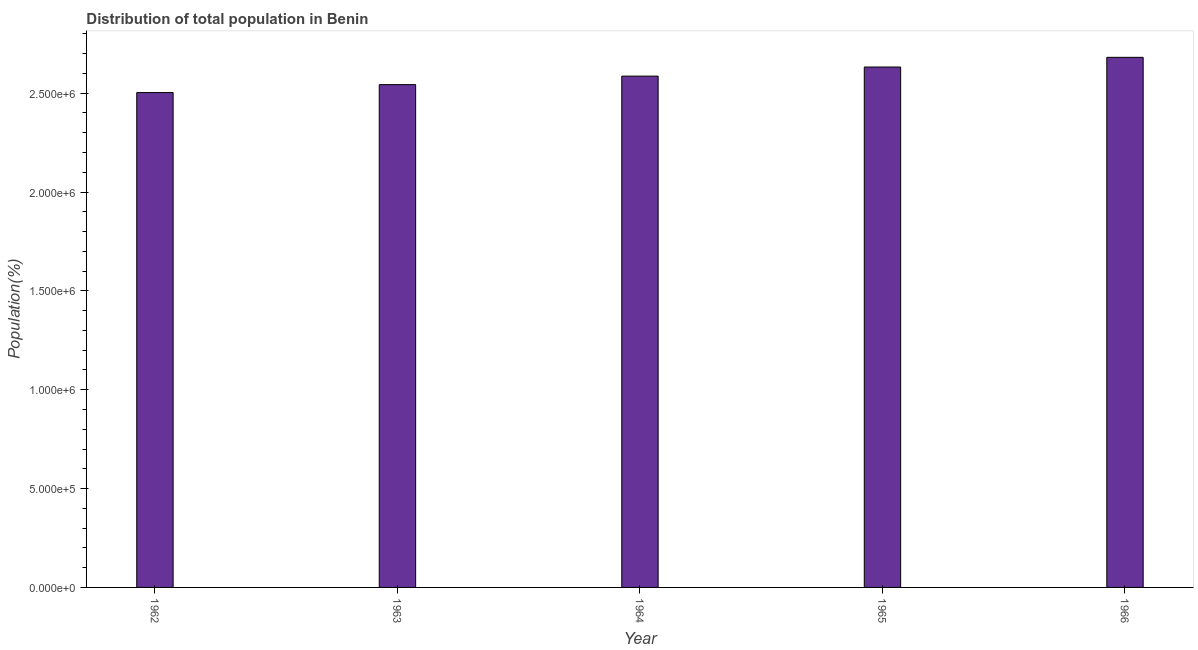Does the graph contain any zero values?
Make the answer very short. No. Does the graph contain grids?
Offer a terse response. No. What is the title of the graph?
Offer a terse response. Distribution of total population in Benin . What is the label or title of the Y-axis?
Provide a succinct answer. Population(%). What is the population in 1965?
Offer a very short reply. 2.63e+06. Across all years, what is the maximum population?
Your response must be concise. 2.68e+06. Across all years, what is the minimum population?
Your answer should be very brief. 2.50e+06. In which year was the population maximum?
Your answer should be very brief. 1966. What is the sum of the population?
Provide a short and direct response. 1.29e+07. What is the difference between the population in 1963 and 1964?
Offer a terse response. -4.30e+04. What is the average population per year?
Your answer should be compact. 2.59e+06. What is the median population?
Your answer should be very brief. 2.59e+06. What is the ratio of the population in 1965 to that in 1966?
Make the answer very short. 0.98. Is the difference between the population in 1963 and 1966 greater than the difference between any two years?
Provide a succinct answer. No. What is the difference between the highest and the second highest population?
Your answer should be very brief. 4.90e+04. What is the difference between the highest and the lowest population?
Provide a short and direct response. 1.78e+05. How many bars are there?
Your response must be concise. 5. How many years are there in the graph?
Give a very brief answer. 5. What is the Population(%) of 1962?
Your response must be concise. 2.50e+06. What is the Population(%) of 1963?
Provide a short and direct response. 2.54e+06. What is the Population(%) in 1964?
Provide a short and direct response. 2.59e+06. What is the Population(%) in 1965?
Make the answer very short. 2.63e+06. What is the Population(%) of 1966?
Give a very brief answer. 2.68e+06. What is the difference between the Population(%) in 1962 and 1963?
Offer a very short reply. -4.01e+04. What is the difference between the Population(%) in 1962 and 1964?
Offer a very short reply. -8.31e+04. What is the difference between the Population(%) in 1962 and 1965?
Provide a short and direct response. -1.29e+05. What is the difference between the Population(%) in 1962 and 1966?
Give a very brief answer. -1.78e+05. What is the difference between the Population(%) in 1963 and 1964?
Your answer should be very brief. -4.30e+04. What is the difference between the Population(%) in 1963 and 1965?
Provide a succinct answer. -8.90e+04. What is the difference between the Population(%) in 1963 and 1966?
Your answer should be very brief. -1.38e+05. What is the difference between the Population(%) in 1964 and 1965?
Your answer should be very brief. -4.60e+04. What is the difference between the Population(%) in 1964 and 1966?
Your response must be concise. -9.50e+04. What is the difference between the Population(%) in 1965 and 1966?
Provide a short and direct response. -4.90e+04. What is the ratio of the Population(%) in 1962 to that in 1964?
Ensure brevity in your answer.  0.97. What is the ratio of the Population(%) in 1962 to that in 1965?
Give a very brief answer. 0.95. What is the ratio of the Population(%) in 1962 to that in 1966?
Offer a very short reply. 0.93. What is the ratio of the Population(%) in 1963 to that in 1964?
Keep it short and to the point. 0.98. What is the ratio of the Population(%) in 1963 to that in 1965?
Your response must be concise. 0.97. What is the ratio of the Population(%) in 1963 to that in 1966?
Your response must be concise. 0.95. 